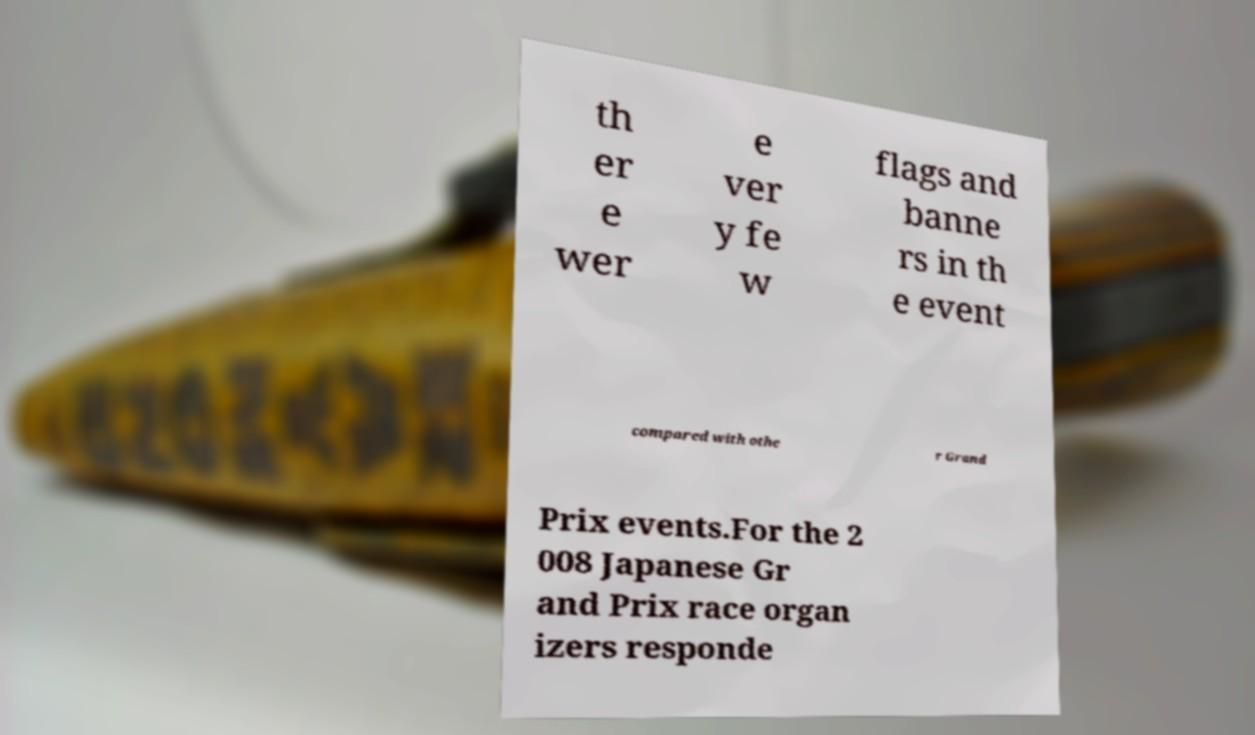For documentation purposes, I need the text within this image transcribed. Could you provide that? th er e wer e ver y fe w flags and banne rs in th e event compared with othe r Grand Prix events.For the 2 008 Japanese Gr and Prix race organ izers responde 